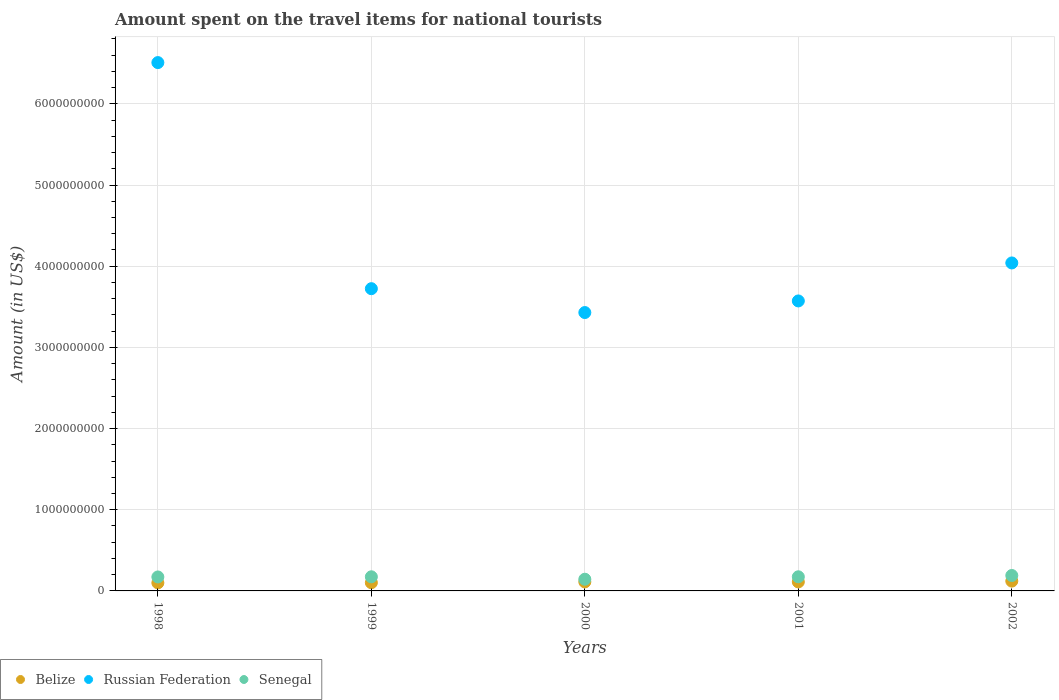What is the amount spent on the travel items for national tourists in Senegal in 2001?
Provide a succinct answer. 1.74e+08. Across all years, what is the maximum amount spent on the travel items for national tourists in Belize?
Ensure brevity in your answer.  1.21e+08. Across all years, what is the minimum amount spent on the travel items for national tourists in Senegal?
Ensure brevity in your answer.  1.44e+08. What is the total amount spent on the travel items for national tourists in Senegal in the graph?
Offer a terse response. 8.54e+08. What is the difference between the amount spent on the travel items for national tourists in Belize in 1999 and that in 2001?
Provide a succinct answer. -1.00e+07. What is the difference between the amount spent on the travel items for national tourists in Russian Federation in 2002 and the amount spent on the travel items for national tourists in Belize in 1999?
Your response must be concise. 3.94e+09. What is the average amount spent on the travel items for national tourists in Senegal per year?
Offer a very short reply. 1.71e+08. In the year 2000, what is the difference between the amount spent on the travel items for national tourists in Senegal and amount spent on the travel items for national tourists in Belize?
Provide a succinct answer. 3.30e+07. What is the ratio of the amount spent on the travel items for national tourists in Senegal in 1998 to that in 1999?
Ensure brevity in your answer.  0.99. What is the difference between the highest and the second highest amount spent on the travel items for national tourists in Russian Federation?
Your answer should be very brief. 2.47e+09. What is the difference between the highest and the lowest amount spent on the travel items for national tourists in Belize?
Make the answer very short. 2.20e+07. Is the sum of the amount spent on the travel items for national tourists in Senegal in 1999 and 2000 greater than the maximum amount spent on the travel items for national tourists in Belize across all years?
Offer a terse response. Yes. Is it the case that in every year, the sum of the amount spent on the travel items for national tourists in Senegal and amount spent on the travel items for national tourists in Russian Federation  is greater than the amount spent on the travel items for national tourists in Belize?
Keep it short and to the point. Yes. Is the amount spent on the travel items for national tourists in Russian Federation strictly greater than the amount spent on the travel items for national tourists in Senegal over the years?
Ensure brevity in your answer.  Yes. Is the amount spent on the travel items for national tourists in Belize strictly less than the amount spent on the travel items for national tourists in Russian Federation over the years?
Ensure brevity in your answer.  Yes. How many dotlines are there?
Your response must be concise. 3. Are the values on the major ticks of Y-axis written in scientific E-notation?
Ensure brevity in your answer.  No. Does the graph contain grids?
Give a very brief answer. Yes. Where does the legend appear in the graph?
Keep it short and to the point. Bottom left. How many legend labels are there?
Your response must be concise. 3. What is the title of the graph?
Provide a succinct answer. Amount spent on the travel items for national tourists. Does "Bosnia and Herzegovina" appear as one of the legend labels in the graph?
Keep it short and to the point. No. What is the Amount (in US$) in Belize in 1998?
Make the answer very short. 9.90e+07. What is the Amount (in US$) of Russian Federation in 1998?
Make the answer very short. 6.51e+09. What is the Amount (in US$) of Senegal in 1998?
Provide a succinct answer. 1.72e+08. What is the Amount (in US$) in Belize in 1999?
Offer a terse response. 1.01e+08. What is the Amount (in US$) of Russian Federation in 1999?
Your answer should be compact. 3.72e+09. What is the Amount (in US$) in Senegal in 1999?
Keep it short and to the point. 1.74e+08. What is the Amount (in US$) of Belize in 2000?
Offer a terse response. 1.11e+08. What is the Amount (in US$) of Russian Federation in 2000?
Keep it short and to the point. 3.43e+09. What is the Amount (in US$) of Senegal in 2000?
Your answer should be very brief. 1.44e+08. What is the Amount (in US$) in Belize in 2001?
Ensure brevity in your answer.  1.11e+08. What is the Amount (in US$) of Russian Federation in 2001?
Offer a very short reply. 3.57e+09. What is the Amount (in US$) of Senegal in 2001?
Offer a terse response. 1.74e+08. What is the Amount (in US$) in Belize in 2002?
Your response must be concise. 1.21e+08. What is the Amount (in US$) in Russian Federation in 2002?
Make the answer very short. 4.04e+09. What is the Amount (in US$) in Senegal in 2002?
Give a very brief answer. 1.90e+08. Across all years, what is the maximum Amount (in US$) of Belize?
Offer a terse response. 1.21e+08. Across all years, what is the maximum Amount (in US$) of Russian Federation?
Keep it short and to the point. 6.51e+09. Across all years, what is the maximum Amount (in US$) in Senegal?
Your response must be concise. 1.90e+08. Across all years, what is the minimum Amount (in US$) of Belize?
Provide a short and direct response. 9.90e+07. Across all years, what is the minimum Amount (in US$) in Russian Federation?
Keep it short and to the point. 3.43e+09. Across all years, what is the minimum Amount (in US$) of Senegal?
Make the answer very short. 1.44e+08. What is the total Amount (in US$) of Belize in the graph?
Keep it short and to the point. 5.43e+08. What is the total Amount (in US$) of Russian Federation in the graph?
Give a very brief answer. 2.13e+1. What is the total Amount (in US$) of Senegal in the graph?
Keep it short and to the point. 8.54e+08. What is the difference between the Amount (in US$) of Russian Federation in 1998 and that in 1999?
Your answer should be compact. 2.78e+09. What is the difference between the Amount (in US$) in Belize in 1998 and that in 2000?
Give a very brief answer. -1.20e+07. What is the difference between the Amount (in US$) of Russian Federation in 1998 and that in 2000?
Make the answer very short. 3.08e+09. What is the difference between the Amount (in US$) in Senegal in 1998 and that in 2000?
Make the answer very short. 2.80e+07. What is the difference between the Amount (in US$) of Belize in 1998 and that in 2001?
Make the answer very short. -1.20e+07. What is the difference between the Amount (in US$) of Russian Federation in 1998 and that in 2001?
Give a very brief answer. 2.94e+09. What is the difference between the Amount (in US$) of Belize in 1998 and that in 2002?
Make the answer very short. -2.20e+07. What is the difference between the Amount (in US$) in Russian Federation in 1998 and that in 2002?
Offer a very short reply. 2.47e+09. What is the difference between the Amount (in US$) of Senegal in 1998 and that in 2002?
Your answer should be compact. -1.80e+07. What is the difference between the Amount (in US$) in Belize in 1999 and that in 2000?
Provide a succinct answer. -1.00e+07. What is the difference between the Amount (in US$) in Russian Federation in 1999 and that in 2000?
Offer a terse response. 2.94e+08. What is the difference between the Amount (in US$) in Senegal in 1999 and that in 2000?
Ensure brevity in your answer.  3.00e+07. What is the difference between the Amount (in US$) in Belize in 1999 and that in 2001?
Your answer should be very brief. -1.00e+07. What is the difference between the Amount (in US$) in Russian Federation in 1999 and that in 2001?
Your answer should be compact. 1.51e+08. What is the difference between the Amount (in US$) in Belize in 1999 and that in 2002?
Provide a succinct answer. -2.00e+07. What is the difference between the Amount (in US$) in Russian Federation in 1999 and that in 2002?
Offer a terse response. -3.17e+08. What is the difference between the Amount (in US$) of Senegal in 1999 and that in 2002?
Provide a succinct answer. -1.60e+07. What is the difference between the Amount (in US$) of Russian Federation in 2000 and that in 2001?
Keep it short and to the point. -1.43e+08. What is the difference between the Amount (in US$) in Senegal in 2000 and that in 2001?
Offer a terse response. -3.00e+07. What is the difference between the Amount (in US$) of Belize in 2000 and that in 2002?
Your answer should be compact. -1.00e+07. What is the difference between the Amount (in US$) in Russian Federation in 2000 and that in 2002?
Ensure brevity in your answer.  -6.11e+08. What is the difference between the Amount (in US$) in Senegal in 2000 and that in 2002?
Keep it short and to the point. -4.60e+07. What is the difference between the Amount (in US$) of Belize in 2001 and that in 2002?
Provide a short and direct response. -1.00e+07. What is the difference between the Amount (in US$) of Russian Federation in 2001 and that in 2002?
Your response must be concise. -4.68e+08. What is the difference between the Amount (in US$) of Senegal in 2001 and that in 2002?
Your answer should be very brief. -1.60e+07. What is the difference between the Amount (in US$) of Belize in 1998 and the Amount (in US$) of Russian Federation in 1999?
Your answer should be compact. -3.62e+09. What is the difference between the Amount (in US$) in Belize in 1998 and the Amount (in US$) in Senegal in 1999?
Your answer should be very brief. -7.50e+07. What is the difference between the Amount (in US$) of Russian Federation in 1998 and the Amount (in US$) of Senegal in 1999?
Keep it short and to the point. 6.33e+09. What is the difference between the Amount (in US$) in Belize in 1998 and the Amount (in US$) in Russian Federation in 2000?
Keep it short and to the point. -3.33e+09. What is the difference between the Amount (in US$) of Belize in 1998 and the Amount (in US$) of Senegal in 2000?
Provide a short and direct response. -4.50e+07. What is the difference between the Amount (in US$) in Russian Federation in 1998 and the Amount (in US$) in Senegal in 2000?
Make the answer very short. 6.36e+09. What is the difference between the Amount (in US$) of Belize in 1998 and the Amount (in US$) of Russian Federation in 2001?
Your answer should be very brief. -3.47e+09. What is the difference between the Amount (in US$) of Belize in 1998 and the Amount (in US$) of Senegal in 2001?
Provide a succinct answer. -7.50e+07. What is the difference between the Amount (in US$) in Russian Federation in 1998 and the Amount (in US$) in Senegal in 2001?
Your answer should be very brief. 6.33e+09. What is the difference between the Amount (in US$) of Belize in 1998 and the Amount (in US$) of Russian Federation in 2002?
Provide a succinct answer. -3.94e+09. What is the difference between the Amount (in US$) of Belize in 1998 and the Amount (in US$) of Senegal in 2002?
Ensure brevity in your answer.  -9.10e+07. What is the difference between the Amount (in US$) in Russian Federation in 1998 and the Amount (in US$) in Senegal in 2002?
Provide a short and direct response. 6.32e+09. What is the difference between the Amount (in US$) of Belize in 1999 and the Amount (in US$) of Russian Federation in 2000?
Keep it short and to the point. -3.33e+09. What is the difference between the Amount (in US$) of Belize in 1999 and the Amount (in US$) of Senegal in 2000?
Your response must be concise. -4.30e+07. What is the difference between the Amount (in US$) of Russian Federation in 1999 and the Amount (in US$) of Senegal in 2000?
Give a very brief answer. 3.58e+09. What is the difference between the Amount (in US$) in Belize in 1999 and the Amount (in US$) in Russian Federation in 2001?
Your answer should be compact. -3.47e+09. What is the difference between the Amount (in US$) in Belize in 1999 and the Amount (in US$) in Senegal in 2001?
Your answer should be very brief. -7.30e+07. What is the difference between the Amount (in US$) of Russian Federation in 1999 and the Amount (in US$) of Senegal in 2001?
Your response must be concise. 3.55e+09. What is the difference between the Amount (in US$) in Belize in 1999 and the Amount (in US$) in Russian Federation in 2002?
Offer a terse response. -3.94e+09. What is the difference between the Amount (in US$) of Belize in 1999 and the Amount (in US$) of Senegal in 2002?
Give a very brief answer. -8.90e+07. What is the difference between the Amount (in US$) in Russian Federation in 1999 and the Amount (in US$) in Senegal in 2002?
Your answer should be very brief. 3.53e+09. What is the difference between the Amount (in US$) of Belize in 2000 and the Amount (in US$) of Russian Federation in 2001?
Your answer should be compact. -3.46e+09. What is the difference between the Amount (in US$) of Belize in 2000 and the Amount (in US$) of Senegal in 2001?
Provide a succinct answer. -6.30e+07. What is the difference between the Amount (in US$) of Russian Federation in 2000 and the Amount (in US$) of Senegal in 2001?
Make the answer very short. 3.26e+09. What is the difference between the Amount (in US$) of Belize in 2000 and the Amount (in US$) of Russian Federation in 2002?
Offer a very short reply. -3.93e+09. What is the difference between the Amount (in US$) of Belize in 2000 and the Amount (in US$) of Senegal in 2002?
Give a very brief answer. -7.90e+07. What is the difference between the Amount (in US$) of Russian Federation in 2000 and the Amount (in US$) of Senegal in 2002?
Your answer should be very brief. 3.24e+09. What is the difference between the Amount (in US$) in Belize in 2001 and the Amount (in US$) in Russian Federation in 2002?
Provide a succinct answer. -3.93e+09. What is the difference between the Amount (in US$) in Belize in 2001 and the Amount (in US$) in Senegal in 2002?
Give a very brief answer. -7.90e+07. What is the difference between the Amount (in US$) of Russian Federation in 2001 and the Amount (in US$) of Senegal in 2002?
Offer a terse response. 3.38e+09. What is the average Amount (in US$) in Belize per year?
Give a very brief answer. 1.09e+08. What is the average Amount (in US$) of Russian Federation per year?
Ensure brevity in your answer.  4.25e+09. What is the average Amount (in US$) in Senegal per year?
Your answer should be very brief. 1.71e+08. In the year 1998, what is the difference between the Amount (in US$) in Belize and Amount (in US$) in Russian Federation?
Make the answer very short. -6.41e+09. In the year 1998, what is the difference between the Amount (in US$) in Belize and Amount (in US$) in Senegal?
Provide a succinct answer. -7.30e+07. In the year 1998, what is the difference between the Amount (in US$) of Russian Federation and Amount (in US$) of Senegal?
Provide a short and direct response. 6.34e+09. In the year 1999, what is the difference between the Amount (in US$) in Belize and Amount (in US$) in Russian Federation?
Offer a terse response. -3.62e+09. In the year 1999, what is the difference between the Amount (in US$) in Belize and Amount (in US$) in Senegal?
Provide a short and direct response. -7.30e+07. In the year 1999, what is the difference between the Amount (in US$) in Russian Federation and Amount (in US$) in Senegal?
Your answer should be compact. 3.55e+09. In the year 2000, what is the difference between the Amount (in US$) of Belize and Amount (in US$) of Russian Federation?
Ensure brevity in your answer.  -3.32e+09. In the year 2000, what is the difference between the Amount (in US$) of Belize and Amount (in US$) of Senegal?
Ensure brevity in your answer.  -3.30e+07. In the year 2000, what is the difference between the Amount (in US$) of Russian Federation and Amount (in US$) of Senegal?
Your answer should be very brief. 3.28e+09. In the year 2001, what is the difference between the Amount (in US$) of Belize and Amount (in US$) of Russian Federation?
Provide a succinct answer. -3.46e+09. In the year 2001, what is the difference between the Amount (in US$) of Belize and Amount (in US$) of Senegal?
Provide a succinct answer. -6.30e+07. In the year 2001, what is the difference between the Amount (in US$) of Russian Federation and Amount (in US$) of Senegal?
Provide a short and direct response. 3.40e+09. In the year 2002, what is the difference between the Amount (in US$) of Belize and Amount (in US$) of Russian Federation?
Give a very brief answer. -3.92e+09. In the year 2002, what is the difference between the Amount (in US$) of Belize and Amount (in US$) of Senegal?
Keep it short and to the point. -6.90e+07. In the year 2002, what is the difference between the Amount (in US$) of Russian Federation and Amount (in US$) of Senegal?
Provide a succinct answer. 3.85e+09. What is the ratio of the Amount (in US$) of Belize in 1998 to that in 1999?
Your response must be concise. 0.98. What is the ratio of the Amount (in US$) in Russian Federation in 1998 to that in 1999?
Your answer should be very brief. 1.75. What is the ratio of the Amount (in US$) in Belize in 1998 to that in 2000?
Provide a succinct answer. 0.89. What is the ratio of the Amount (in US$) in Russian Federation in 1998 to that in 2000?
Your answer should be very brief. 1.9. What is the ratio of the Amount (in US$) in Senegal in 1998 to that in 2000?
Your answer should be compact. 1.19. What is the ratio of the Amount (in US$) of Belize in 1998 to that in 2001?
Make the answer very short. 0.89. What is the ratio of the Amount (in US$) in Russian Federation in 1998 to that in 2001?
Give a very brief answer. 1.82. What is the ratio of the Amount (in US$) in Belize in 1998 to that in 2002?
Provide a short and direct response. 0.82. What is the ratio of the Amount (in US$) in Russian Federation in 1998 to that in 2002?
Your response must be concise. 1.61. What is the ratio of the Amount (in US$) in Senegal in 1998 to that in 2002?
Ensure brevity in your answer.  0.91. What is the ratio of the Amount (in US$) in Belize in 1999 to that in 2000?
Your response must be concise. 0.91. What is the ratio of the Amount (in US$) of Russian Federation in 1999 to that in 2000?
Provide a succinct answer. 1.09. What is the ratio of the Amount (in US$) of Senegal in 1999 to that in 2000?
Your answer should be compact. 1.21. What is the ratio of the Amount (in US$) of Belize in 1999 to that in 2001?
Your response must be concise. 0.91. What is the ratio of the Amount (in US$) in Russian Federation in 1999 to that in 2001?
Offer a very short reply. 1.04. What is the ratio of the Amount (in US$) in Belize in 1999 to that in 2002?
Offer a very short reply. 0.83. What is the ratio of the Amount (in US$) in Russian Federation in 1999 to that in 2002?
Keep it short and to the point. 0.92. What is the ratio of the Amount (in US$) of Senegal in 1999 to that in 2002?
Keep it short and to the point. 0.92. What is the ratio of the Amount (in US$) of Russian Federation in 2000 to that in 2001?
Keep it short and to the point. 0.96. What is the ratio of the Amount (in US$) in Senegal in 2000 to that in 2001?
Your answer should be very brief. 0.83. What is the ratio of the Amount (in US$) in Belize in 2000 to that in 2002?
Provide a short and direct response. 0.92. What is the ratio of the Amount (in US$) of Russian Federation in 2000 to that in 2002?
Offer a terse response. 0.85. What is the ratio of the Amount (in US$) in Senegal in 2000 to that in 2002?
Give a very brief answer. 0.76. What is the ratio of the Amount (in US$) in Belize in 2001 to that in 2002?
Your response must be concise. 0.92. What is the ratio of the Amount (in US$) of Russian Federation in 2001 to that in 2002?
Provide a short and direct response. 0.88. What is the ratio of the Amount (in US$) of Senegal in 2001 to that in 2002?
Make the answer very short. 0.92. What is the difference between the highest and the second highest Amount (in US$) in Russian Federation?
Ensure brevity in your answer.  2.47e+09. What is the difference between the highest and the second highest Amount (in US$) of Senegal?
Offer a terse response. 1.60e+07. What is the difference between the highest and the lowest Amount (in US$) in Belize?
Keep it short and to the point. 2.20e+07. What is the difference between the highest and the lowest Amount (in US$) of Russian Federation?
Your answer should be compact. 3.08e+09. What is the difference between the highest and the lowest Amount (in US$) in Senegal?
Ensure brevity in your answer.  4.60e+07. 